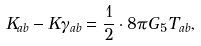Convert formula to latex. <formula><loc_0><loc_0><loc_500><loc_500>K _ { a b } - K \gamma _ { a b } = \frac { 1 } { 2 } \cdot 8 \pi G _ { 5 } T _ { a b } ,</formula> 